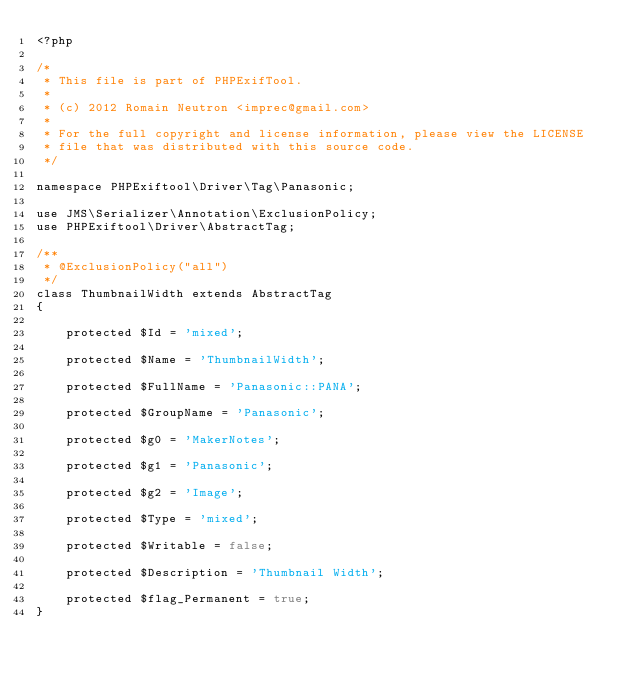<code> <loc_0><loc_0><loc_500><loc_500><_PHP_><?php

/*
 * This file is part of PHPExifTool.
 *
 * (c) 2012 Romain Neutron <imprec@gmail.com>
 *
 * For the full copyright and license information, please view the LICENSE
 * file that was distributed with this source code.
 */

namespace PHPExiftool\Driver\Tag\Panasonic;

use JMS\Serializer\Annotation\ExclusionPolicy;
use PHPExiftool\Driver\AbstractTag;

/**
 * @ExclusionPolicy("all")
 */
class ThumbnailWidth extends AbstractTag
{

    protected $Id = 'mixed';

    protected $Name = 'ThumbnailWidth';

    protected $FullName = 'Panasonic::PANA';

    protected $GroupName = 'Panasonic';

    protected $g0 = 'MakerNotes';

    protected $g1 = 'Panasonic';

    protected $g2 = 'Image';

    protected $Type = 'mixed';

    protected $Writable = false;

    protected $Description = 'Thumbnail Width';

    protected $flag_Permanent = true;
}
</code> 